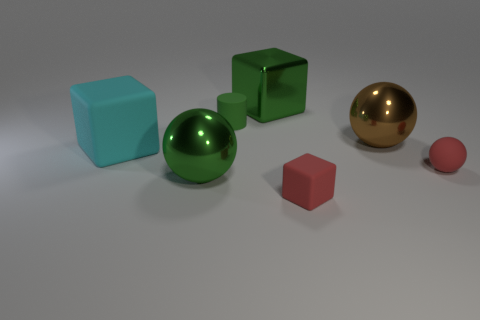The other red object that is the same shape as the large matte thing is what size?
Offer a terse response. Small. There is a tiny block that is the same color as the matte ball; what material is it?
Offer a very short reply. Rubber. What number of tiny matte spheres are the same color as the small block?
Your response must be concise. 1. There is a big shiny sphere behind the big cyan matte object; is its color the same as the matte block on the right side of the cyan cube?
Keep it short and to the point. No. Are there any large green cubes in front of the big cyan block?
Keep it short and to the point. No. There is a block that is both to the right of the big green sphere and behind the green metallic ball; what is its material?
Ensure brevity in your answer.  Metal. Are the red thing behind the red matte cube and the big cyan cube made of the same material?
Offer a very short reply. Yes. What is the material of the small cube?
Make the answer very short. Rubber. What is the size of the sphere that is to the left of the tiny red rubber block?
Keep it short and to the point. Large. Is there anything else that is the same color as the tiny cube?
Your answer should be compact. Yes. 